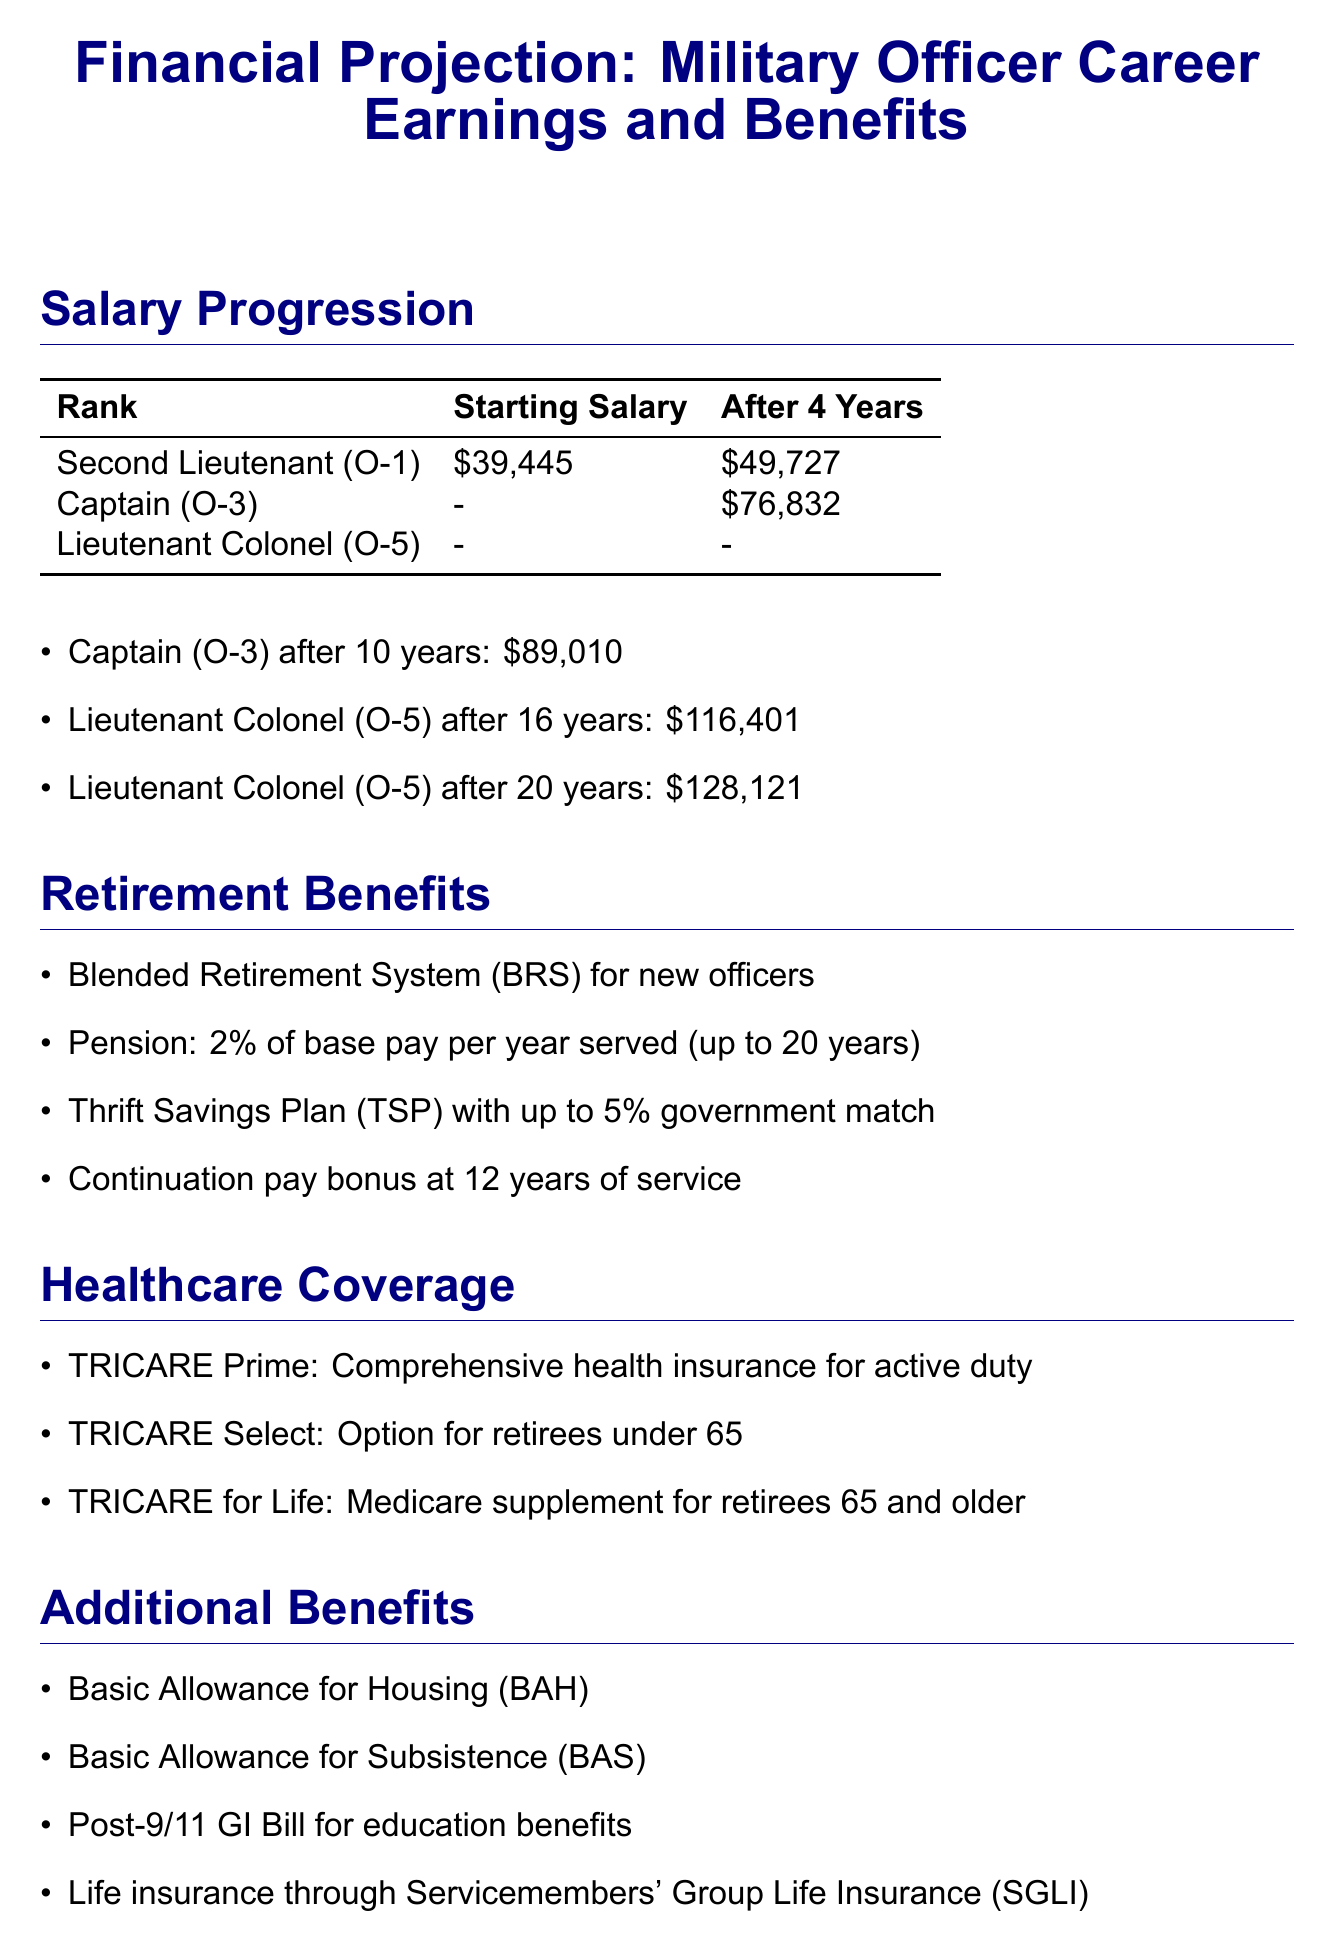what is the starting salary for a Second Lieutenant? The starting salary listed for a Second Lieutenant (O-1) is $39,445.
Answer: $39,445 how much does a Captain earn after 10 years? The document states that a Captain (O-3) earns $89,010 after 10 years.
Answer: $89,010 what percentage of base pay is the pension under the retirement benefits? The pension under the retirement benefits is 2% of base pay per year served (up to 20 years).
Answer: 2% what is the maximum government match for the Thrift Savings Plan? The maximum government match for the Thrift Savings Plan is up to 5%.
Answer: 5% what is the projected 20-year career earnings? The projected 20-year career earnings is approximately $2.5 million.
Answer: Approximately $2.5 million which healthcare coverage is for retirees under 65? The healthcare coverage option for retirees under 65 is TRICARE Select.
Answer: TRICARE Select what is the estimated lifetime value of benefits? The estimated lifetime value of benefits is over $1 million.
Answer: Over $1 million how much retirement income is expected at 20 years of service? The retirement income expected at 20 years is 40% of base pay.
Answer: 40% of base pay what additional benefit provides education funding for veterans? The additional benefit that provides education funding for veterans is the Post-9/11 GI Bill.
Answer: Post-9/11 GI Bill 